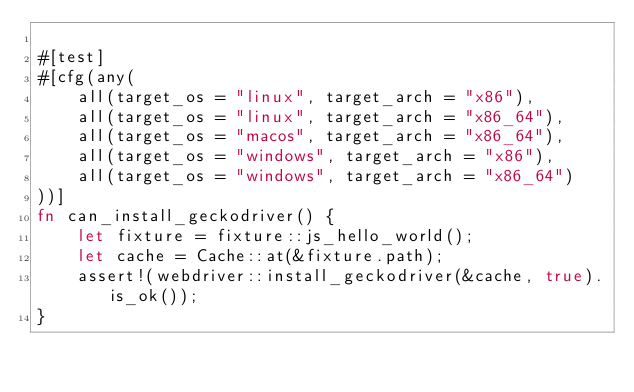Convert code to text. <code><loc_0><loc_0><loc_500><loc_500><_Rust_>
#[test]
#[cfg(any(
    all(target_os = "linux", target_arch = "x86"),
    all(target_os = "linux", target_arch = "x86_64"),
    all(target_os = "macos", target_arch = "x86_64"),
    all(target_os = "windows", target_arch = "x86"),
    all(target_os = "windows", target_arch = "x86_64")
))]
fn can_install_geckodriver() {
    let fixture = fixture::js_hello_world();
    let cache = Cache::at(&fixture.path);
    assert!(webdriver::install_geckodriver(&cache, true).is_ok());
}
</code> 